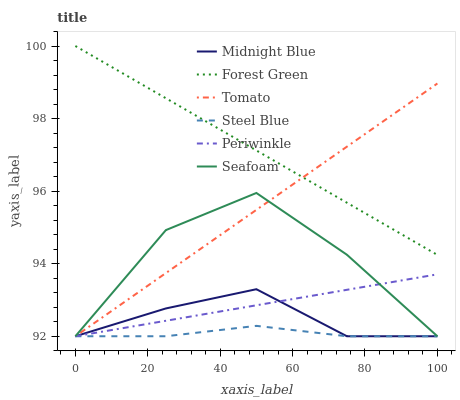Does Steel Blue have the minimum area under the curve?
Answer yes or no. Yes. Does Forest Green have the maximum area under the curve?
Answer yes or no. Yes. Does Midnight Blue have the minimum area under the curve?
Answer yes or no. No. Does Midnight Blue have the maximum area under the curve?
Answer yes or no. No. Is Forest Green the smoothest?
Answer yes or no. Yes. Is Seafoam the roughest?
Answer yes or no. Yes. Is Midnight Blue the smoothest?
Answer yes or no. No. Is Midnight Blue the roughest?
Answer yes or no. No. Does Tomato have the lowest value?
Answer yes or no. Yes. Does Forest Green have the lowest value?
Answer yes or no. No. Does Forest Green have the highest value?
Answer yes or no. Yes. Does Midnight Blue have the highest value?
Answer yes or no. No. Is Seafoam less than Forest Green?
Answer yes or no. Yes. Is Forest Green greater than Periwinkle?
Answer yes or no. Yes. Does Periwinkle intersect Steel Blue?
Answer yes or no. Yes. Is Periwinkle less than Steel Blue?
Answer yes or no. No. Is Periwinkle greater than Steel Blue?
Answer yes or no. No. Does Seafoam intersect Forest Green?
Answer yes or no. No. 